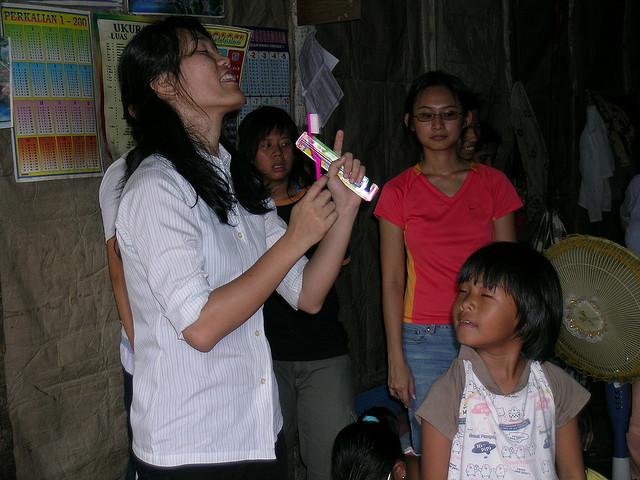Where are the people standing?
Write a very short answer. In room. Is this picture in the United States?
Keep it brief. No. What does the shirt say?
Short answer required. Nothing. What color is the toothbrush the woman is holding?
Short answer required. Pink. Is there more than one red item in the photo?
Keep it brief. No. Are they playing a video game?
Short answer required. No. How many kids have hats?
Write a very short answer. 0. Are the children happy?
Keep it brief. Yes. How many people in this scene are wearing glasses?
Short answer required. 1. Are these kids generally happy?
Quick response, please. Yes. Who is talking?
Short answer required. Woman. 